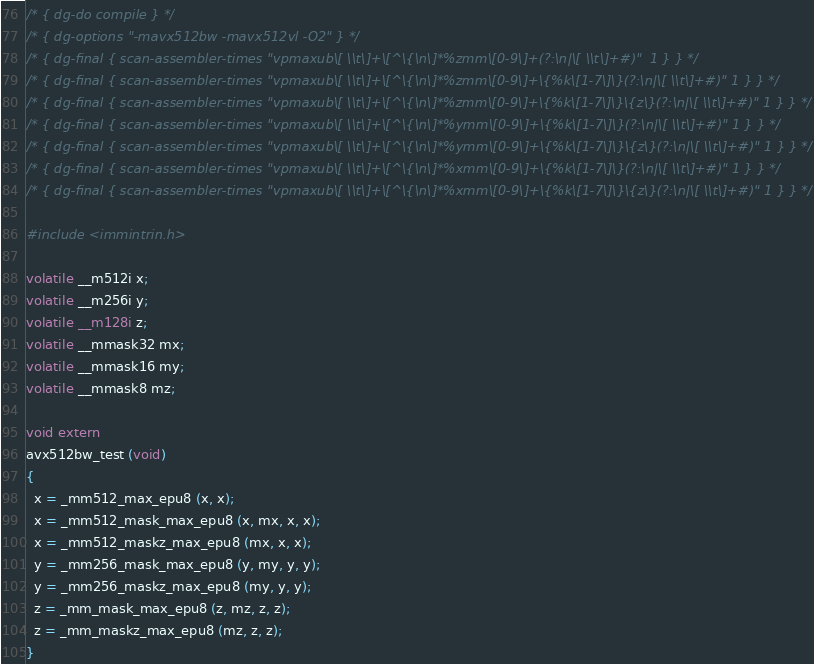<code> <loc_0><loc_0><loc_500><loc_500><_C_>/* { dg-do compile } */
/* { dg-options "-mavx512bw -mavx512vl -O2" } */
/* { dg-final { scan-assembler-times "vpmaxub\[ \\t\]+\[^\{\n\]*%zmm\[0-9\]+(?:\n|\[ \\t\]+#)"  1 } } */
/* { dg-final { scan-assembler-times "vpmaxub\[ \\t\]+\[^\{\n\]*%zmm\[0-9\]+\{%k\[1-7\]\}(?:\n|\[ \\t\]+#)" 1 } } */
/* { dg-final { scan-assembler-times "vpmaxub\[ \\t\]+\[^\{\n\]*%zmm\[0-9\]+\{%k\[1-7\]\}\{z\}(?:\n|\[ \\t\]+#)" 1 } } */
/* { dg-final { scan-assembler-times "vpmaxub\[ \\t\]+\[^\{\n\]*%ymm\[0-9\]+\{%k\[1-7\]\}(?:\n|\[ \\t\]+#)" 1 } } */
/* { dg-final { scan-assembler-times "vpmaxub\[ \\t\]+\[^\{\n\]*%ymm\[0-9\]+\{%k\[1-7\]\}\{z\}(?:\n|\[ \\t\]+#)" 1 } } */
/* { dg-final { scan-assembler-times "vpmaxub\[ \\t\]+\[^\{\n\]*%xmm\[0-9\]+\{%k\[1-7\]\}(?:\n|\[ \\t\]+#)" 1 } } */
/* { dg-final { scan-assembler-times "vpmaxub\[ \\t\]+\[^\{\n\]*%xmm\[0-9\]+\{%k\[1-7\]\}\{z\}(?:\n|\[ \\t\]+#)" 1 } } */

#include <immintrin.h>

volatile __m512i x;
volatile __m256i y;
volatile __m128i z;
volatile __mmask32 mx;
volatile __mmask16 my;
volatile __mmask8 mz;

void extern
avx512bw_test (void)
{
  x = _mm512_max_epu8 (x, x);
  x = _mm512_mask_max_epu8 (x, mx, x, x);
  x = _mm512_maskz_max_epu8 (mx, x, x);
  y = _mm256_mask_max_epu8 (y, my, y, y);
  y = _mm256_maskz_max_epu8 (my, y, y);
  z = _mm_mask_max_epu8 (z, mz, z, z);
  z = _mm_maskz_max_epu8 (mz, z, z);
}
</code> 